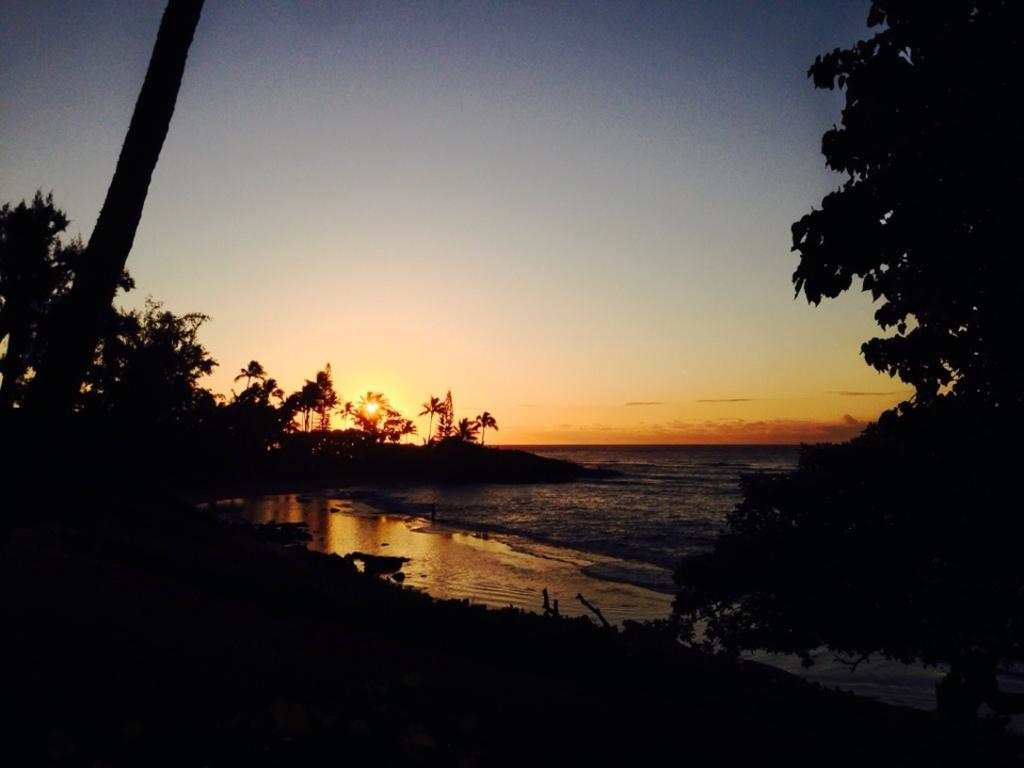What type of vegetation can be seen in the image? There are trees in the image. What natural element is also visible in the image? There is water visible in the image. What part of the natural environment is visible in the image? The sky is visible in the image. How many snails can be seen crawling on the oven in the image? There are no snails or ovens present in the image. 